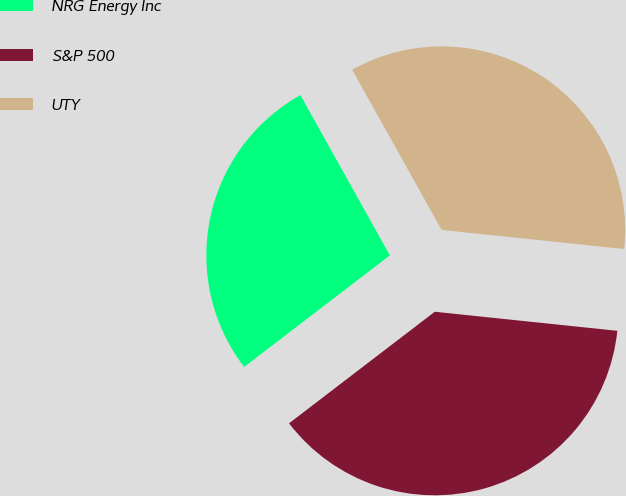Convert chart. <chart><loc_0><loc_0><loc_500><loc_500><pie_chart><fcel>NRG Energy Inc<fcel>S&P 500<fcel>UTY<nl><fcel>27.29%<fcel>37.94%<fcel>34.76%<nl></chart> 